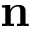Convert formula to latex. <formula><loc_0><loc_0><loc_500><loc_500>n</formula> 